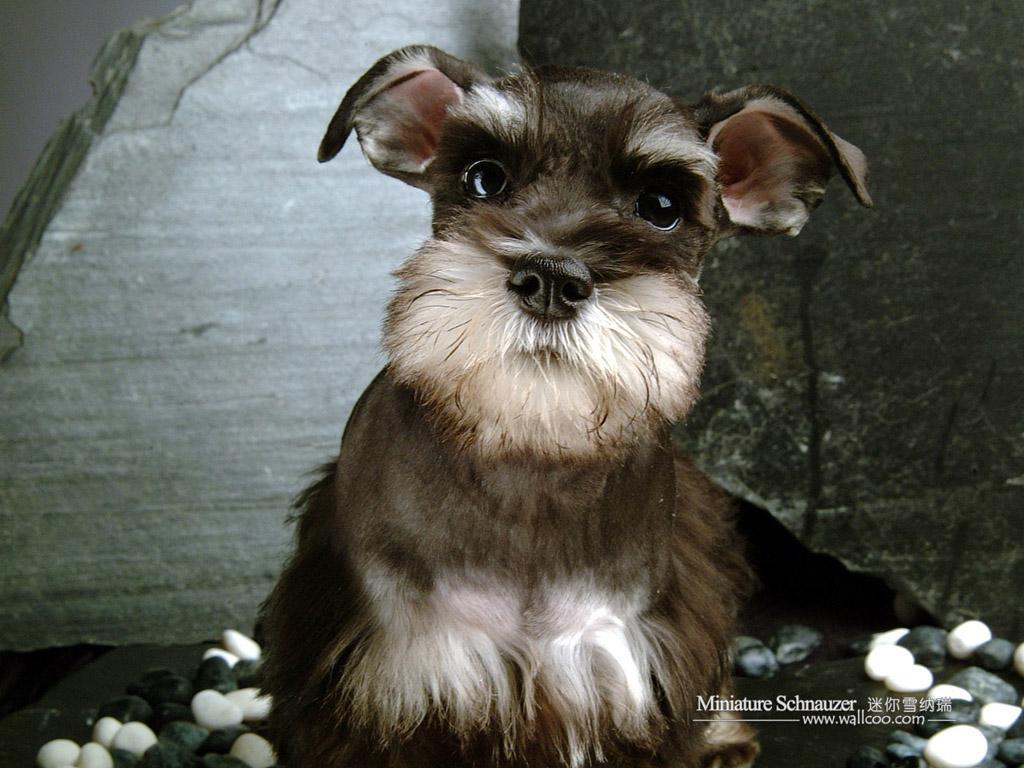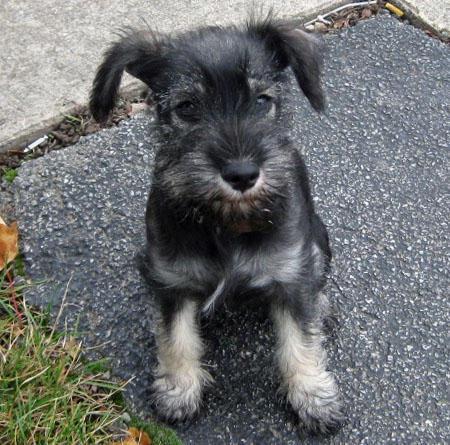The first image is the image on the left, the second image is the image on the right. For the images shown, is this caption "Left image features a schnauzer dog sitting inside a car on a seat." true? Answer yes or no. No. 